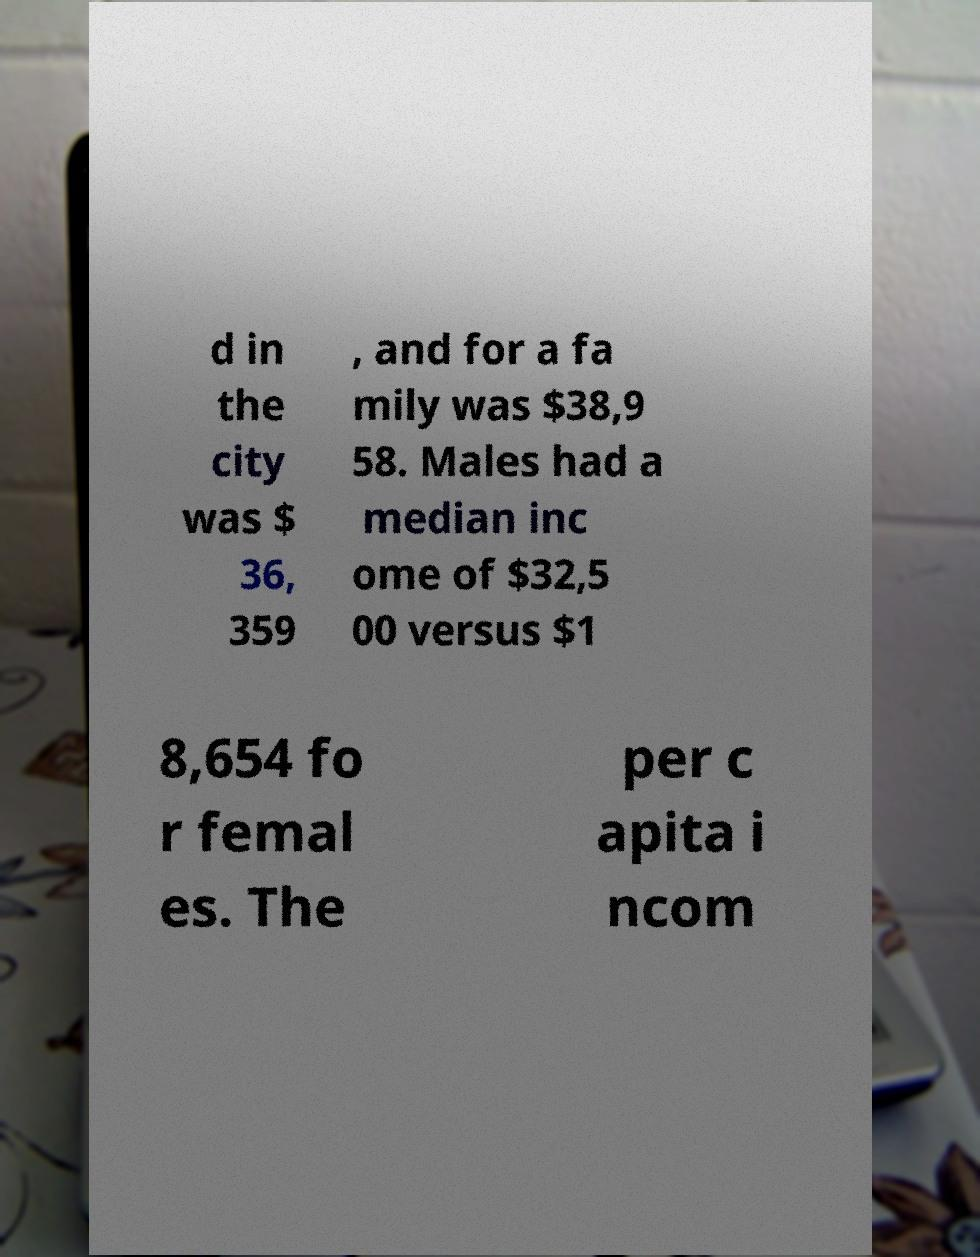There's text embedded in this image that I need extracted. Can you transcribe it verbatim? d in the city was $ 36, 359 , and for a fa mily was $38,9 58. Males had a median inc ome of $32,5 00 versus $1 8,654 fo r femal es. The per c apita i ncom 